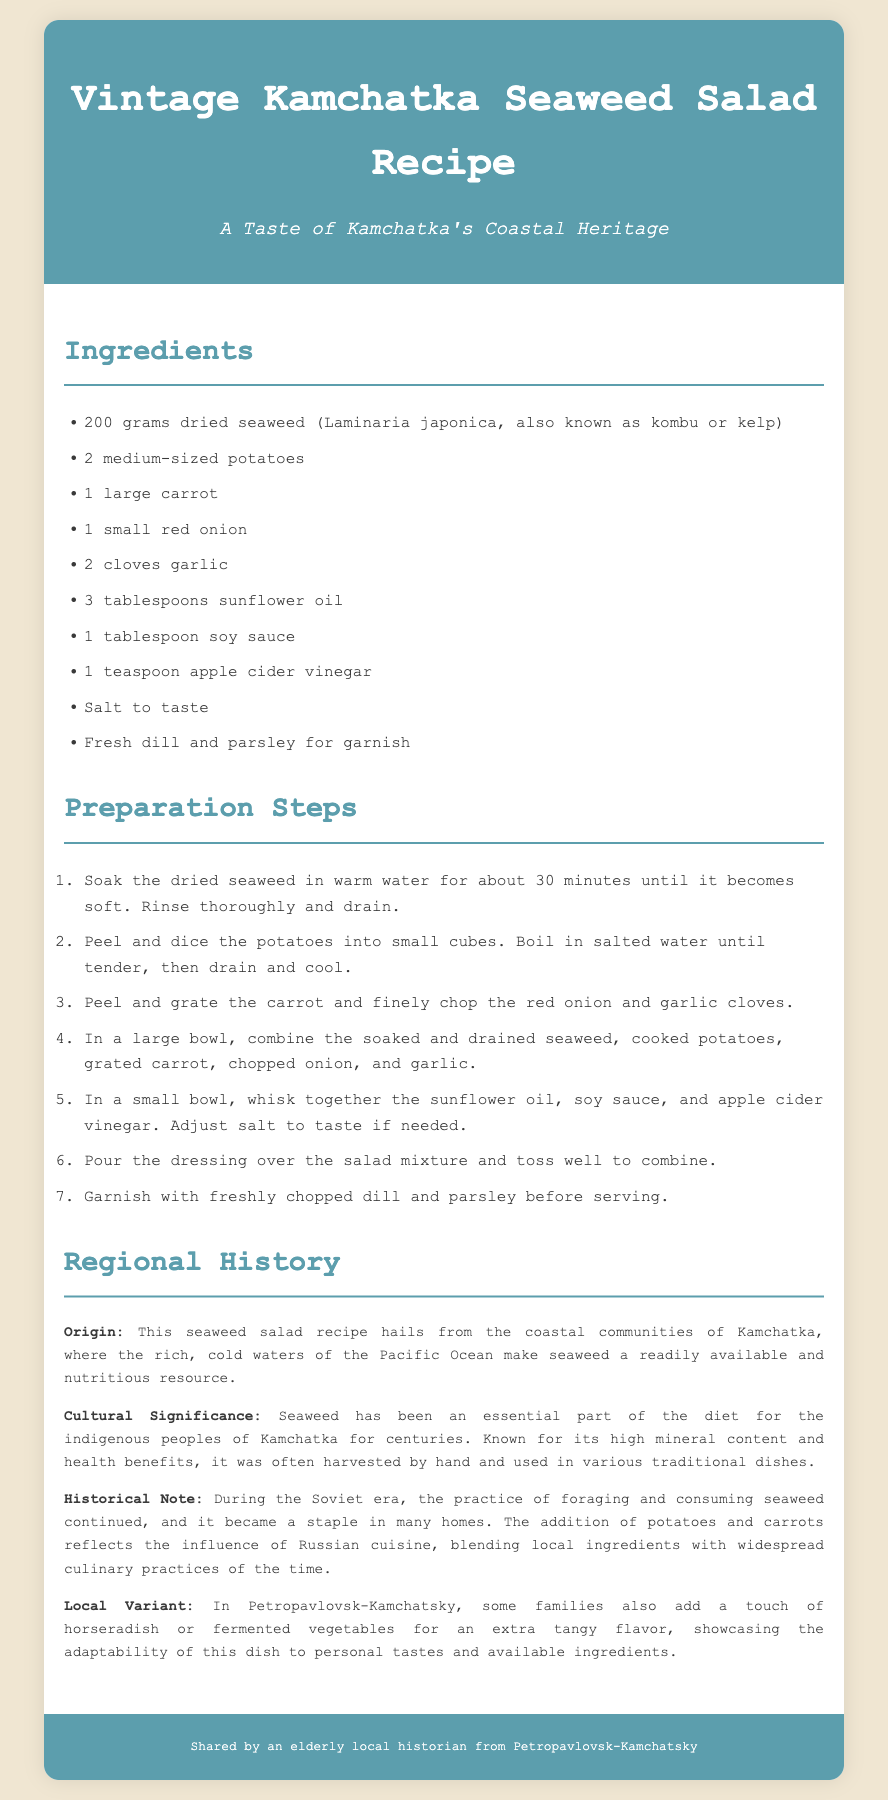What is the main ingredient of the salad? The main ingredient is dried seaweed, specifically Laminaria japonica.
Answer: dried seaweed How many potatoes are used in the recipe? The recipe calls for 2 medium-sized potatoes.
Answer: 2 What is the total number of preparation steps? There are 7 steps listed in the preparation section.
Answer: 7 Where does the recipe originate from? The recipe hails from the coastal communities of Kamchatka.
Answer: Kamchatka What ingredient adds a tangy flavor in local variants? Horseradish is mentioned as an ingredient for extra tangy flavor.
Answer: horseradish What cultural group traditionally consumed seaweed? The indigenous peoples of Kamchatka are noted for their consumption of seaweed.
Answer: indigenous peoples What kind of oil is used in the dressing? Sunflower oil is used in the dressing for the salad.
Answer: sunflower oil What is the purpose of apple cider vinegar in the recipe? Apple cider vinegar is included in the dressing for the salad.
Answer: dressing How long should the seaweed be soaked? The seaweed should be soaked in warm water for about 30 minutes.
Answer: 30 minutes 